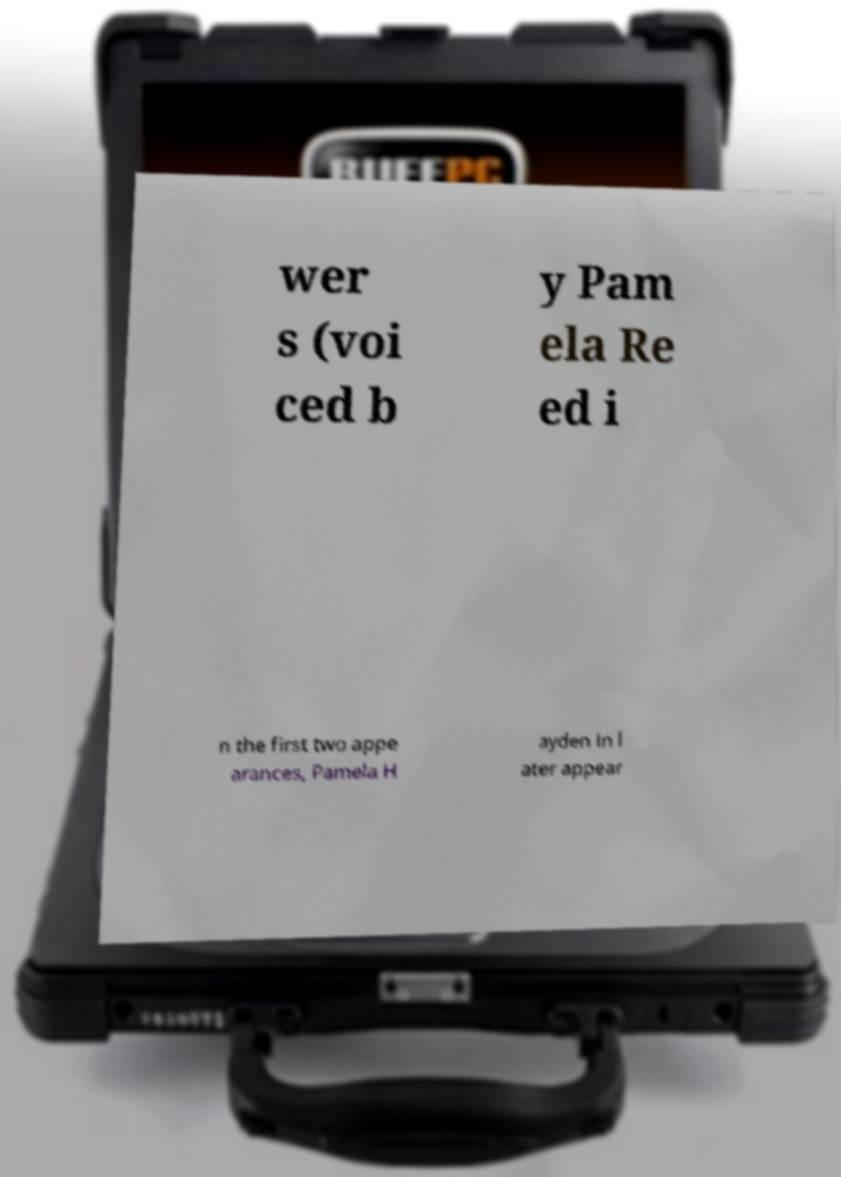Please identify and transcribe the text found in this image. wer s (voi ced b y Pam ela Re ed i n the first two appe arances, Pamela H ayden in l ater appear 